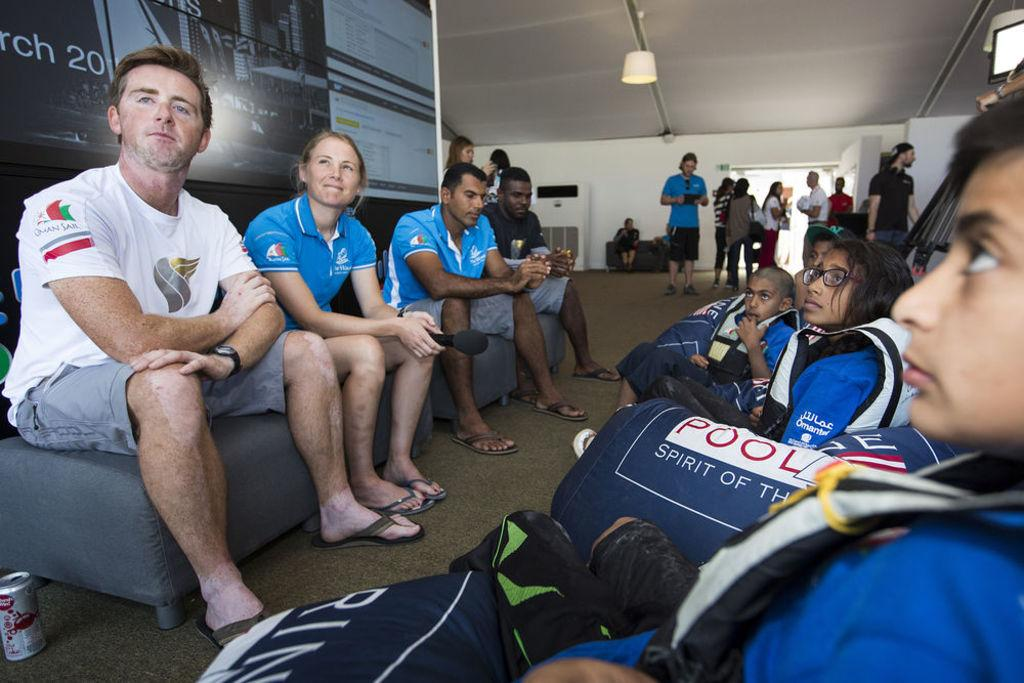<image>
Present a compact description of the photo's key features. The bag on the left has the word pool written on it. 